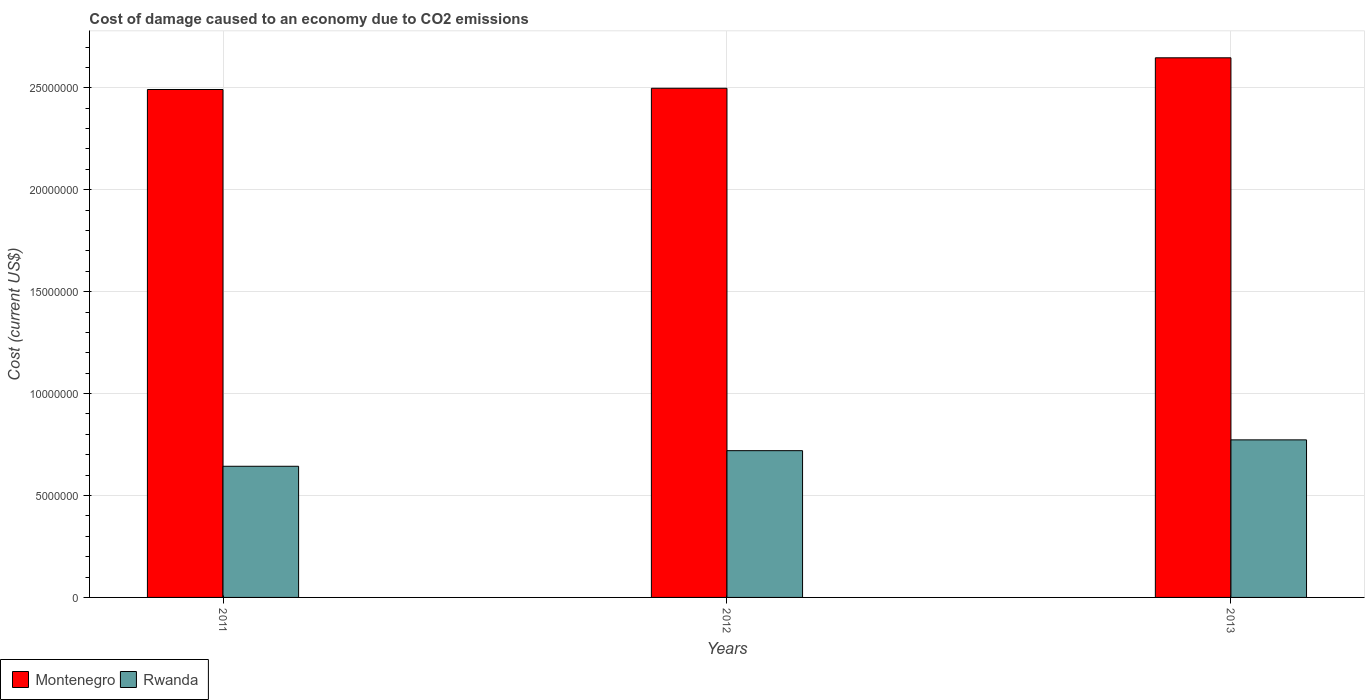Are the number of bars per tick equal to the number of legend labels?
Ensure brevity in your answer.  Yes. Are the number of bars on each tick of the X-axis equal?
Your response must be concise. Yes. How many bars are there on the 2nd tick from the left?
Provide a short and direct response. 2. How many bars are there on the 3rd tick from the right?
Offer a very short reply. 2. What is the label of the 3rd group of bars from the left?
Keep it short and to the point. 2013. In how many cases, is the number of bars for a given year not equal to the number of legend labels?
Provide a succinct answer. 0. What is the cost of damage caused due to CO2 emissisons in Montenegro in 2011?
Offer a terse response. 2.49e+07. Across all years, what is the maximum cost of damage caused due to CO2 emissisons in Rwanda?
Ensure brevity in your answer.  7.73e+06. Across all years, what is the minimum cost of damage caused due to CO2 emissisons in Rwanda?
Provide a succinct answer. 6.43e+06. In which year was the cost of damage caused due to CO2 emissisons in Montenegro minimum?
Offer a terse response. 2011. What is the total cost of damage caused due to CO2 emissisons in Montenegro in the graph?
Provide a succinct answer. 7.64e+07. What is the difference between the cost of damage caused due to CO2 emissisons in Rwanda in 2011 and that in 2013?
Give a very brief answer. -1.30e+06. What is the difference between the cost of damage caused due to CO2 emissisons in Rwanda in 2012 and the cost of damage caused due to CO2 emissisons in Montenegro in 2013?
Provide a short and direct response. -1.93e+07. What is the average cost of damage caused due to CO2 emissisons in Montenegro per year?
Provide a succinct answer. 2.55e+07. In the year 2012, what is the difference between the cost of damage caused due to CO2 emissisons in Montenegro and cost of damage caused due to CO2 emissisons in Rwanda?
Your answer should be very brief. 1.78e+07. What is the ratio of the cost of damage caused due to CO2 emissisons in Rwanda in 2011 to that in 2013?
Your answer should be compact. 0.83. Is the cost of damage caused due to CO2 emissisons in Montenegro in 2012 less than that in 2013?
Give a very brief answer. Yes. What is the difference between the highest and the second highest cost of damage caused due to CO2 emissisons in Rwanda?
Your answer should be very brief. 5.30e+05. What is the difference between the highest and the lowest cost of damage caused due to CO2 emissisons in Montenegro?
Your answer should be compact. 1.56e+06. Is the sum of the cost of damage caused due to CO2 emissisons in Rwanda in 2011 and 2013 greater than the maximum cost of damage caused due to CO2 emissisons in Montenegro across all years?
Make the answer very short. No. What does the 2nd bar from the left in 2012 represents?
Offer a terse response. Rwanda. What does the 1st bar from the right in 2013 represents?
Your answer should be very brief. Rwanda. How many bars are there?
Ensure brevity in your answer.  6. How many years are there in the graph?
Offer a very short reply. 3. Does the graph contain grids?
Give a very brief answer. Yes. Where does the legend appear in the graph?
Offer a very short reply. Bottom left. How are the legend labels stacked?
Your answer should be very brief. Horizontal. What is the title of the graph?
Your response must be concise. Cost of damage caused to an economy due to CO2 emissions. What is the label or title of the Y-axis?
Your response must be concise. Cost (current US$). What is the Cost (current US$) of Montenegro in 2011?
Keep it short and to the point. 2.49e+07. What is the Cost (current US$) in Rwanda in 2011?
Offer a very short reply. 6.43e+06. What is the Cost (current US$) of Montenegro in 2012?
Make the answer very short. 2.50e+07. What is the Cost (current US$) of Rwanda in 2012?
Give a very brief answer. 7.20e+06. What is the Cost (current US$) in Montenegro in 2013?
Keep it short and to the point. 2.65e+07. What is the Cost (current US$) of Rwanda in 2013?
Provide a short and direct response. 7.73e+06. Across all years, what is the maximum Cost (current US$) of Montenegro?
Provide a succinct answer. 2.65e+07. Across all years, what is the maximum Cost (current US$) of Rwanda?
Provide a succinct answer. 7.73e+06. Across all years, what is the minimum Cost (current US$) in Montenegro?
Provide a succinct answer. 2.49e+07. Across all years, what is the minimum Cost (current US$) of Rwanda?
Offer a very short reply. 6.43e+06. What is the total Cost (current US$) of Montenegro in the graph?
Provide a succinct answer. 7.64e+07. What is the total Cost (current US$) in Rwanda in the graph?
Provide a succinct answer. 2.14e+07. What is the difference between the Cost (current US$) in Montenegro in 2011 and that in 2012?
Make the answer very short. -6.16e+04. What is the difference between the Cost (current US$) in Rwanda in 2011 and that in 2012?
Your answer should be very brief. -7.66e+05. What is the difference between the Cost (current US$) in Montenegro in 2011 and that in 2013?
Provide a short and direct response. -1.56e+06. What is the difference between the Cost (current US$) of Rwanda in 2011 and that in 2013?
Your answer should be very brief. -1.30e+06. What is the difference between the Cost (current US$) of Montenegro in 2012 and that in 2013?
Give a very brief answer. -1.49e+06. What is the difference between the Cost (current US$) of Rwanda in 2012 and that in 2013?
Give a very brief answer. -5.30e+05. What is the difference between the Cost (current US$) in Montenegro in 2011 and the Cost (current US$) in Rwanda in 2012?
Give a very brief answer. 1.77e+07. What is the difference between the Cost (current US$) in Montenegro in 2011 and the Cost (current US$) in Rwanda in 2013?
Your answer should be compact. 1.72e+07. What is the difference between the Cost (current US$) of Montenegro in 2012 and the Cost (current US$) of Rwanda in 2013?
Keep it short and to the point. 1.72e+07. What is the average Cost (current US$) of Montenegro per year?
Your answer should be very brief. 2.55e+07. What is the average Cost (current US$) of Rwanda per year?
Give a very brief answer. 7.12e+06. In the year 2011, what is the difference between the Cost (current US$) of Montenegro and Cost (current US$) of Rwanda?
Your answer should be compact. 1.85e+07. In the year 2012, what is the difference between the Cost (current US$) of Montenegro and Cost (current US$) of Rwanda?
Provide a short and direct response. 1.78e+07. In the year 2013, what is the difference between the Cost (current US$) of Montenegro and Cost (current US$) of Rwanda?
Provide a short and direct response. 1.87e+07. What is the ratio of the Cost (current US$) of Rwanda in 2011 to that in 2012?
Provide a short and direct response. 0.89. What is the ratio of the Cost (current US$) in Montenegro in 2011 to that in 2013?
Provide a succinct answer. 0.94. What is the ratio of the Cost (current US$) in Rwanda in 2011 to that in 2013?
Ensure brevity in your answer.  0.83. What is the ratio of the Cost (current US$) in Montenegro in 2012 to that in 2013?
Keep it short and to the point. 0.94. What is the ratio of the Cost (current US$) of Rwanda in 2012 to that in 2013?
Give a very brief answer. 0.93. What is the difference between the highest and the second highest Cost (current US$) of Montenegro?
Ensure brevity in your answer.  1.49e+06. What is the difference between the highest and the second highest Cost (current US$) in Rwanda?
Your answer should be compact. 5.30e+05. What is the difference between the highest and the lowest Cost (current US$) in Montenegro?
Offer a very short reply. 1.56e+06. What is the difference between the highest and the lowest Cost (current US$) of Rwanda?
Make the answer very short. 1.30e+06. 